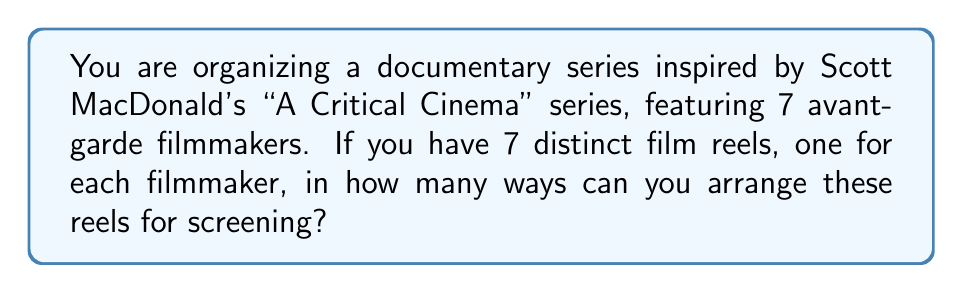Can you answer this question? Let's approach this step-by-step:

1) This is a permutation problem. We need to arrange 7 distinct items (film reels) in a specific order.

2) In permutation problems, the order matters. Each different arrangement is considered a unique permutation.

3) We have 7 choices for the first reel, 6 for the second, 5 for the third, and so on.

4) This can be represented mathematically as:

   $$7 \times 6 \times 5 \times 4 \times 3 \times 2 \times 1$$

5) This is also known as 7 factorial, denoted as $7!$

6) Let's calculate:
   
   $$7! = 7 \times 6 \times 5 \times 4 \times 3 \times 2 \times 1 = 5040$$

Therefore, there are 5040 ways to arrange the 7 film reels.
Answer: $7! = 5040$ 